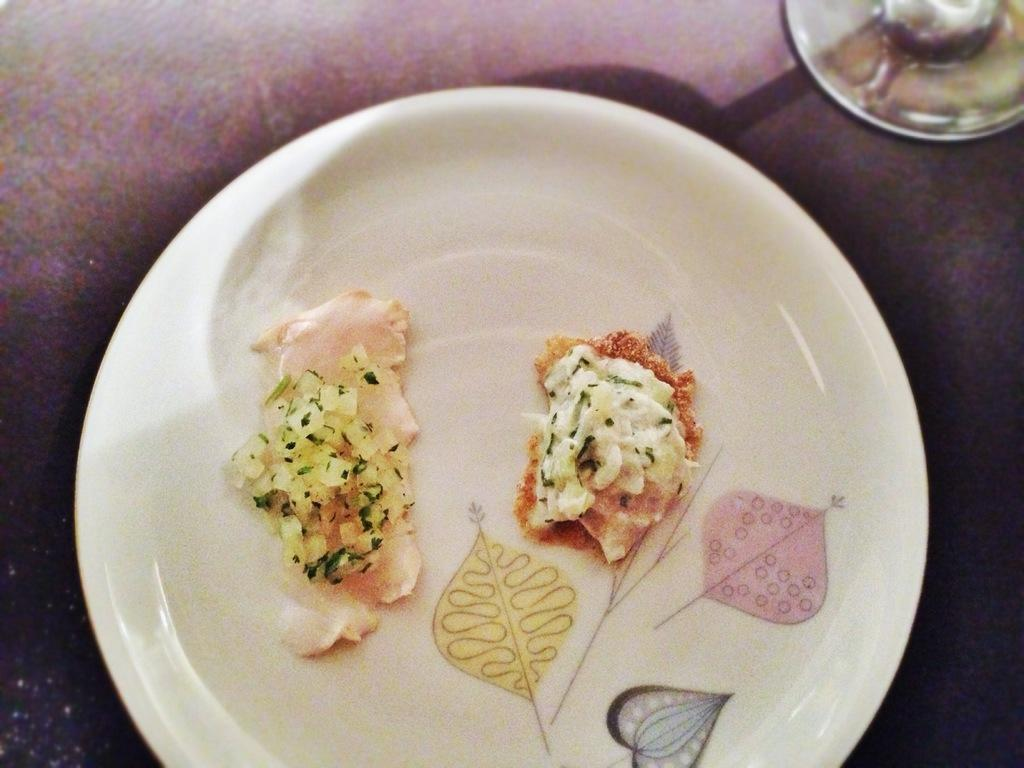What is the main object in the center of the image? There is a plate in the center of the image. What is on the plate? There are food items on the plate. What other dish is present in the image? There is a bowl beside the plate. What type of bushes can be seen growing around the food items in the image? There are no bushes present in the image; it only features a plate with food items and a bowl beside it. 